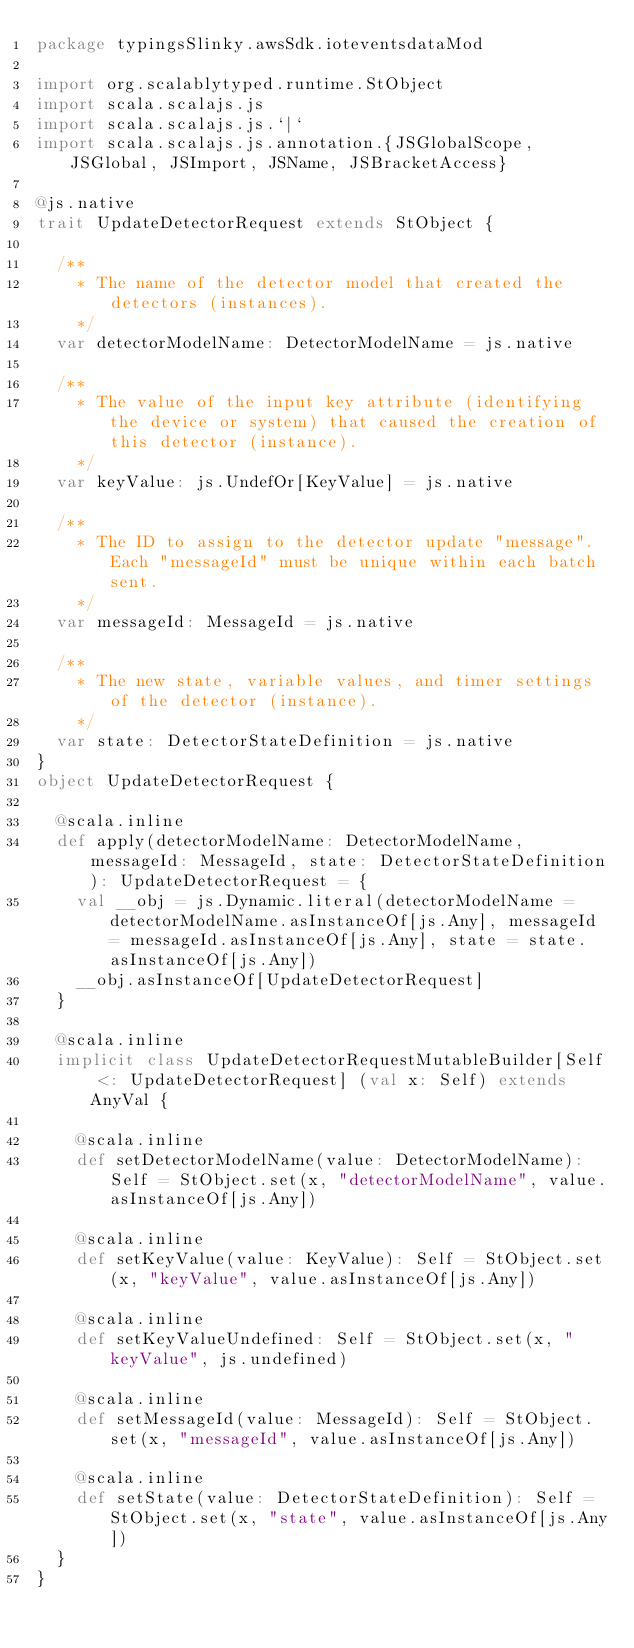<code> <loc_0><loc_0><loc_500><loc_500><_Scala_>package typingsSlinky.awsSdk.ioteventsdataMod

import org.scalablytyped.runtime.StObject
import scala.scalajs.js
import scala.scalajs.js.`|`
import scala.scalajs.js.annotation.{JSGlobalScope, JSGlobal, JSImport, JSName, JSBracketAccess}

@js.native
trait UpdateDetectorRequest extends StObject {
  
  /**
    * The name of the detector model that created the detectors (instances).
    */
  var detectorModelName: DetectorModelName = js.native
  
  /**
    * The value of the input key attribute (identifying the device or system) that caused the creation of this detector (instance).
    */
  var keyValue: js.UndefOr[KeyValue] = js.native
  
  /**
    * The ID to assign to the detector update "message". Each "messageId" must be unique within each batch sent.
    */
  var messageId: MessageId = js.native
  
  /**
    * The new state, variable values, and timer settings of the detector (instance).
    */
  var state: DetectorStateDefinition = js.native
}
object UpdateDetectorRequest {
  
  @scala.inline
  def apply(detectorModelName: DetectorModelName, messageId: MessageId, state: DetectorStateDefinition): UpdateDetectorRequest = {
    val __obj = js.Dynamic.literal(detectorModelName = detectorModelName.asInstanceOf[js.Any], messageId = messageId.asInstanceOf[js.Any], state = state.asInstanceOf[js.Any])
    __obj.asInstanceOf[UpdateDetectorRequest]
  }
  
  @scala.inline
  implicit class UpdateDetectorRequestMutableBuilder[Self <: UpdateDetectorRequest] (val x: Self) extends AnyVal {
    
    @scala.inline
    def setDetectorModelName(value: DetectorModelName): Self = StObject.set(x, "detectorModelName", value.asInstanceOf[js.Any])
    
    @scala.inline
    def setKeyValue(value: KeyValue): Self = StObject.set(x, "keyValue", value.asInstanceOf[js.Any])
    
    @scala.inline
    def setKeyValueUndefined: Self = StObject.set(x, "keyValue", js.undefined)
    
    @scala.inline
    def setMessageId(value: MessageId): Self = StObject.set(x, "messageId", value.asInstanceOf[js.Any])
    
    @scala.inline
    def setState(value: DetectorStateDefinition): Self = StObject.set(x, "state", value.asInstanceOf[js.Any])
  }
}
</code> 